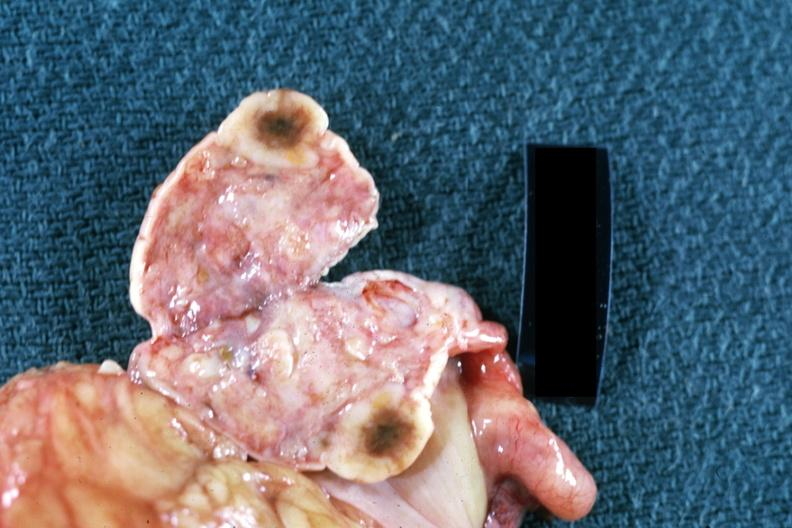where does this belong to?
Answer the question using a single word or phrase. Female reproductive system 